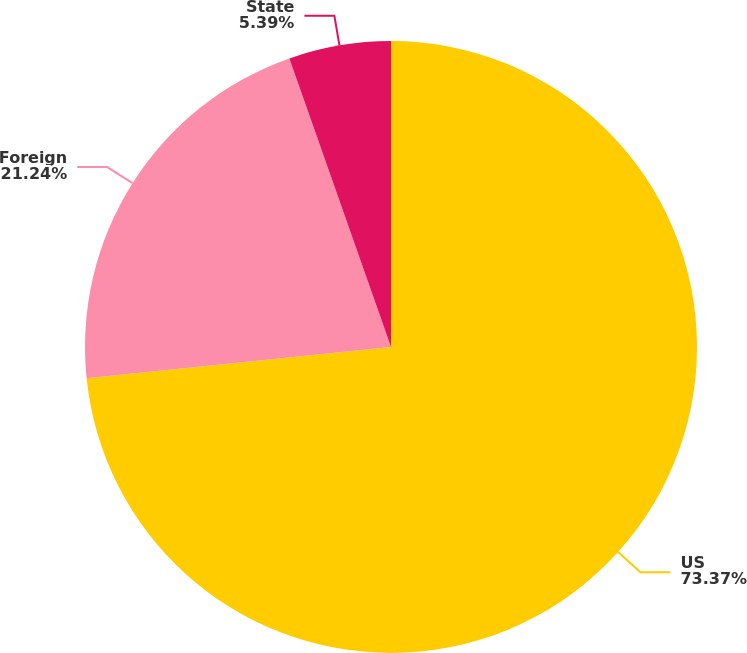Convert chart. <chart><loc_0><loc_0><loc_500><loc_500><pie_chart><fcel>US<fcel>Foreign<fcel>State<nl><fcel>73.38%<fcel>21.24%<fcel>5.39%<nl></chart> 